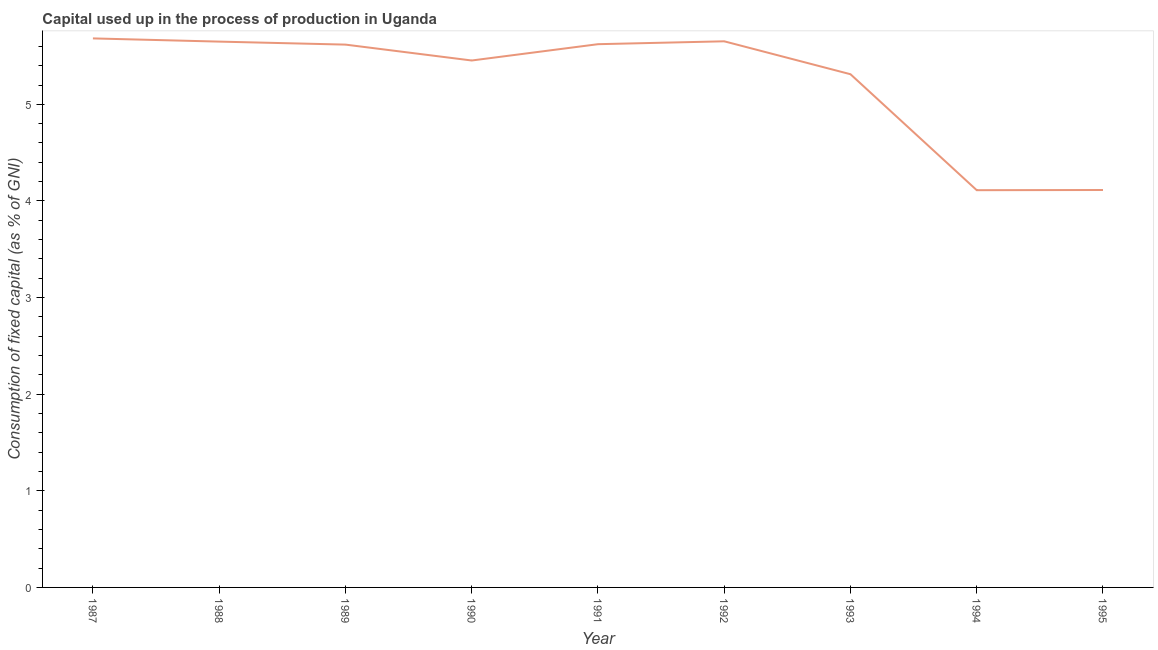What is the consumption of fixed capital in 1989?
Your answer should be very brief. 5.62. Across all years, what is the maximum consumption of fixed capital?
Give a very brief answer. 5.68. Across all years, what is the minimum consumption of fixed capital?
Offer a terse response. 4.11. What is the sum of the consumption of fixed capital?
Provide a succinct answer. 47.21. What is the difference between the consumption of fixed capital in 1987 and 1988?
Keep it short and to the point. 0.03. What is the average consumption of fixed capital per year?
Keep it short and to the point. 5.25. What is the median consumption of fixed capital?
Offer a very short reply. 5.62. In how many years, is the consumption of fixed capital greater than 2.2 %?
Make the answer very short. 9. What is the ratio of the consumption of fixed capital in 1987 to that in 1993?
Provide a succinct answer. 1.07. Is the consumption of fixed capital in 1987 less than that in 1993?
Provide a short and direct response. No. What is the difference between the highest and the second highest consumption of fixed capital?
Offer a terse response. 0.03. Is the sum of the consumption of fixed capital in 1992 and 1993 greater than the maximum consumption of fixed capital across all years?
Offer a terse response. Yes. What is the difference between the highest and the lowest consumption of fixed capital?
Ensure brevity in your answer.  1.57. Does the consumption of fixed capital monotonically increase over the years?
Make the answer very short. No. How many years are there in the graph?
Make the answer very short. 9. Are the values on the major ticks of Y-axis written in scientific E-notation?
Ensure brevity in your answer.  No. Does the graph contain any zero values?
Make the answer very short. No. What is the title of the graph?
Your answer should be very brief. Capital used up in the process of production in Uganda. What is the label or title of the X-axis?
Provide a short and direct response. Year. What is the label or title of the Y-axis?
Your response must be concise. Consumption of fixed capital (as % of GNI). What is the Consumption of fixed capital (as % of GNI) of 1987?
Ensure brevity in your answer.  5.68. What is the Consumption of fixed capital (as % of GNI) in 1988?
Ensure brevity in your answer.  5.65. What is the Consumption of fixed capital (as % of GNI) of 1989?
Offer a very short reply. 5.62. What is the Consumption of fixed capital (as % of GNI) in 1990?
Ensure brevity in your answer.  5.45. What is the Consumption of fixed capital (as % of GNI) in 1991?
Give a very brief answer. 5.62. What is the Consumption of fixed capital (as % of GNI) in 1992?
Make the answer very short. 5.65. What is the Consumption of fixed capital (as % of GNI) of 1993?
Offer a very short reply. 5.31. What is the Consumption of fixed capital (as % of GNI) of 1994?
Provide a succinct answer. 4.11. What is the Consumption of fixed capital (as % of GNI) of 1995?
Your response must be concise. 4.11. What is the difference between the Consumption of fixed capital (as % of GNI) in 1987 and 1988?
Offer a terse response. 0.03. What is the difference between the Consumption of fixed capital (as % of GNI) in 1987 and 1989?
Your answer should be very brief. 0.06. What is the difference between the Consumption of fixed capital (as % of GNI) in 1987 and 1990?
Your response must be concise. 0.23. What is the difference between the Consumption of fixed capital (as % of GNI) in 1987 and 1991?
Your answer should be compact. 0.06. What is the difference between the Consumption of fixed capital (as % of GNI) in 1987 and 1992?
Ensure brevity in your answer.  0.03. What is the difference between the Consumption of fixed capital (as % of GNI) in 1987 and 1993?
Provide a succinct answer. 0.37. What is the difference between the Consumption of fixed capital (as % of GNI) in 1987 and 1994?
Offer a terse response. 1.57. What is the difference between the Consumption of fixed capital (as % of GNI) in 1987 and 1995?
Your response must be concise. 1.57. What is the difference between the Consumption of fixed capital (as % of GNI) in 1988 and 1989?
Offer a very short reply. 0.03. What is the difference between the Consumption of fixed capital (as % of GNI) in 1988 and 1990?
Your answer should be compact. 0.2. What is the difference between the Consumption of fixed capital (as % of GNI) in 1988 and 1991?
Give a very brief answer. 0.03. What is the difference between the Consumption of fixed capital (as % of GNI) in 1988 and 1992?
Offer a terse response. -0. What is the difference between the Consumption of fixed capital (as % of GNI) in 1988 and 1993?
Provide a succinct answer. 0.34. What is the difference between the Consumption of fixed capital (as % of GNI) in 1988 and 1994?
Provide a short and direct response. 1.54. What is the difference between the Consumption of fixed capital (as % of GNI) in 1988 and 1995?
Make the answer very short. 1.54. What is the difference between the Consumption of fixed capital (as % of GNI) in 1989 and 1990?
Ensure brevity in your answer.  0.16. What is the difference between the Consumption of fixed capital (as % of GNI) in 1989 and 1991?
Give a very brief answer. -0. What is the difference between the Consumption of fixed capital (as % of GNI) in 1989 and 1992?
Provide a succinct answer. -0.03. What is the difference between the Consumption of fixed capital (as % of GNI) in 1989 and 1993?
Offer a terse response. 0.31. What is the difference between the Consumption of fixed capital (as % of GNI) in 1989 and 1994?
Provide a short and direct response. 1.51. What is the difference between the Consumption of fixed capital (as % of GNI) in 1989 and 1995?
Keep it short and to the point. 1.5. What is the difference between the Consumption of fixed capital (as % of GNI) in 1990 and 1991?
Make the answer very short. -0.17. What is the difference between the Consumption of fixed capital (as % of GNI) in 1990 and 1992?
Provide a succinct answer. -0.2. What is the difference between the Consumption of fixed capital (as % of GNI) in 1990 and 1993?
Provide a short and direct response. 0.14. What is the difference between the Consumption of fixed capital (as % of GNI) in 1990 and 1994?
Keep it short and to the point. 1.34. What is the difference between the Consumption of fixed capital (as % of GNI) in 1990 and 1995?
Give a very brief answer. 1.34. What is the difference between the Consumption of fixed capital (as % of GNI) in 1991 and 1992?
Offer a very short reply. -0.03. What is the difference between the Consumption of fixed capital (as % of GNI) in 1991 and 1993?
Ensure brevity in your answer.  0.31. What is the difference between the Consumption of fixed capital (as % of GNI) in 1991 and 1994?
Your answer should be compact. 1.51. What is the difference between the Consumption of fixed capital (as % of GNI) in 1991 and 1995?
Offer a very short reply. 1.51. What is the difference between the Consumption of fixed capital (as % of GNI) in 1992 and 1993?
Offer a terse response. 0.34. What is the difference between the Consumption of fixed capital (as % of GNI) in 1992 and 1994?
Offer a very short reply. 1.54. What is the difference between the Consumption of fixed capital (as % of GNI) in 1992 and 1995?
Keep it short and to the point. 1.54. What is the difference between the Consumption of fixed capital (as % of GNI) in 1993 and 1994?
Ensure brevity in your answer.  1.2. What is the difference between the Consumption of fixed capital (as % of GNI) in 1993 and 1995?
Your response must be concise. 1.2. What is the difference between the Consumption of fixed capital (as % of GNI) in 1994 and 1995?
Give a very brief answer. -0. What is the ratio of the Consumption of fixed capital (as % of GNI) in 1987 to that in 1988?
Offer a very short reply. 1.01. What is the ratio of the Consumption of fixed capital (as % of GNI) in 1987 to that in 1990?
Give a very brief answer. 1.04. What is the ratio of the Consumption of fixed capital (as % of GNI) in 1987 to that in 1991?
Make the answer very short. 1.01. What is the ratio of the Consumption of fixed capital (as % of GNI) in 1987 to that in 1993?
Give a very brief answer. 1.07. What is the ratio of the Consumption of fixed capital (as % of GNI) in 1987 to that in 1994?
Keep it short and to the point. 1.38. What is the ratio of the Consumption of fixed capital (as % of GNI) in 1987 to that in 1995?
Your response must be concise. 1.38. What is the ratio of the Consumption of fixed capital (as % of GNI) in 1988 to that in 1989?
Provide a short and direct response. 1.01. What is the ratio of the Consumption of fixed capital (as % of GNI) in 1988 to that in 1990?
Keep it short and to the point. 1.04. What is the ratio of the Consumption of fixed capital (as % of GNI) in 1988 to that in 1993?
Offer a very short reply. 1.06. What is the ratio of the Consumption of fixed capital (as % of GNI) in 1988 to that in 1994?
Give a very brief answer. 1.37. What is the ratio of the Consumption of fixed capital (as % of GNI) in 1988 to that in 1995?
Provide a short and direct response. 1.37. What is the ratio of the Consumption of fixed capital (as % of GNI) in 1989 to that in 1991?
Offer a very short reply. 1. What is the ratio of the Consumption of fixed capital (as % of GNI) in 1989 to that in 1993?
Provide a succinct answer. 1.06. What is the ratio of the Consumption of fixed capital (as % of GNI) in 1989 to that in 1994?
Keep it short and to the point. 1.37. What is the ratio of the Consumption of fixed capital (as % of GNI) in 1989 to that in 1995?
Make the answer very short. 1.37. What is the ratio of the Consumption of fixed capital (as % of GNI) in 1990 to that in 1994?
Ensure brevity in your answer.  1.33. What is the ratio of the Consumption of fixed capital (as % of GNI) in 1990 to that in 1995?
Keep it short and to the point. 1.33. What is the ratio of the Consumption of fixed capital (as % of GNI) in 1991 to that in 1993?
Make the answer very short. 1.06. What is the ratio of the Consumption of fixed capital (as % of GNI) in 1991 to that in 1994?
Your answer should be very brief. 1.37. What is the ratio of the Consumption of fixed capital (as % of GNI) in 1991 to that in 1995?
Make the answer very short. 1.37. What is the ratio of the Consumption of fixed capital (as % of GNI) in 1992 to that in 1993?
Your response must be concise. 1.06. What is the ratio of the Consumption of fixed capital (as % of GNI) in 1992 to that in 1994?
Your answer should be very brief. 1.38. What is the ratio of the Consumption of fixed capital (as % of GNI) in 1992 to that in 1995?
Offer a terse response. 1.37. What is the ratio of the Consumption of fixed capital (as % of GNI) in 1993 to that in 1994?
Provide a succinct answer. 1.29. What is the ratio of the Consumption of fixed capital (as % of GNI) in 1993 to that in 1995?
Give a very brief answer. 1.29. What is the ratio of the Consumption of fixed capital (as % of GNI) in 1994 to that in 1995?
Make the answer very short. 1. 